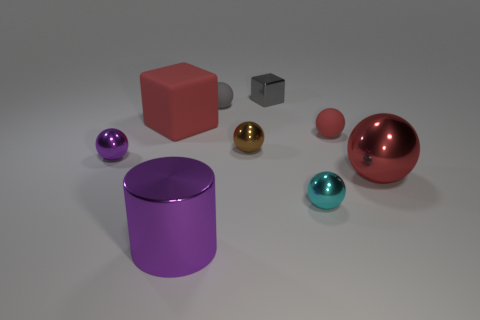There is a purple object that is the same size as the cyan thing; what shape is it?
Keep it short and to the point. Sphere. The metallic thing that is behind the metal cylinder and on the left side of the brown shiny ball is what color?
Your response must be concise. Purple. There is a red ball that is in front of the red matte sphere; is its size the same as the small gray metallic object?
Ensure brevity in your answer.  No. How many things are either small matte things that are behind the large block or purple cubes?
Give a very brief answer. 1. Are there any gray objects that have the same size as the cyan object?
Make the answer very short. Yes. There is a cube that is the same size as the purple shiny cylinder; what is its material?
Give a very brief answer. Rubber. There is a shiny object that is both right of the gray matte object and in front of the large red ball; what shape is it?
Make the answer very short. Sphere. The tiny shiny sphere behind the small purple shiny ball is what color?
Offer a very short reply. Brown. There is a matte thing that is on the right side of the large red matte object and in front of the gray rubber ball; what is its size?
Give a very brief answer. Small. Are the large sphere and the cube that is on the left side of the metal cylinder made of the same material?
Your answer should be compact. No. 